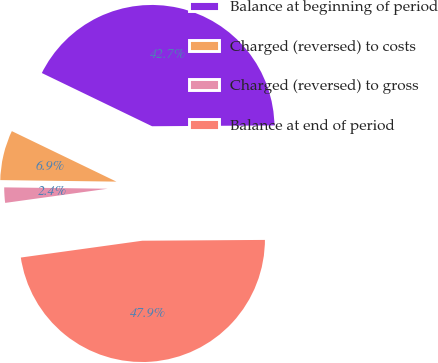Convert chart to OTSL. <chart><loc_0><loc_0><loc_500><loc_500><pie_chart><fcel>Balance at beginning of period<fcel>Charged (reversed) to costs<fcel>Charged (reversed) to gross<fcel>Balance at end of period<nl><fcel>42.74%<fcel>6.95%<fcel>2.4%<fcel>47.92%<nl></chart> 